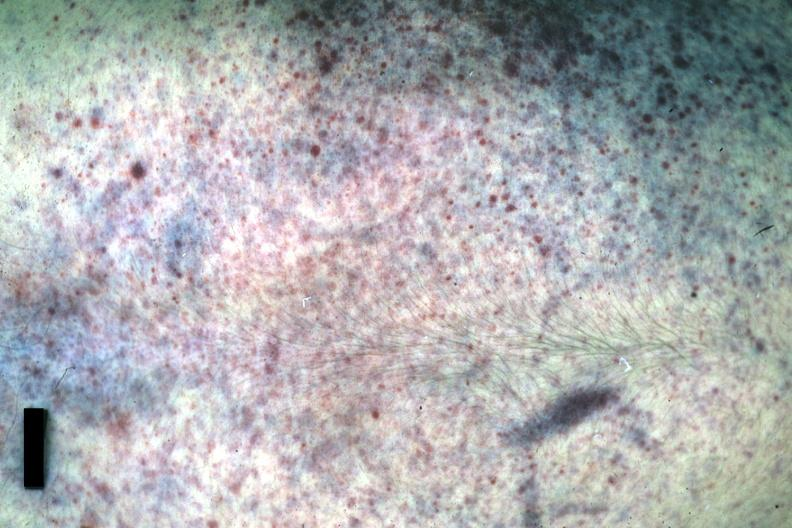s thigh at autopsy present?
Answer the question using a single word or phrase. No 